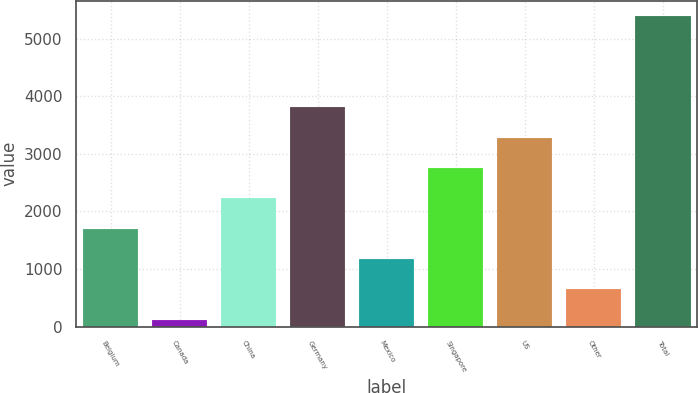<chart> <loc_0><loc_0><loc_500><loc_500><bar_chart><fcel>Belgium<fcel>Canada<fcel>China<fcel>Germany<fcel>Mexico<fcel>Singapore<fcel>US<fcel>Other<fcel>Total<nl><fcel>1702.8<fcel>123<fcel>2229.4<fcel>3809.2<fcel>1176.2<fcel>2756<fcel>3282.6<fcel>649.6<fcel>5389<nl></chart> 